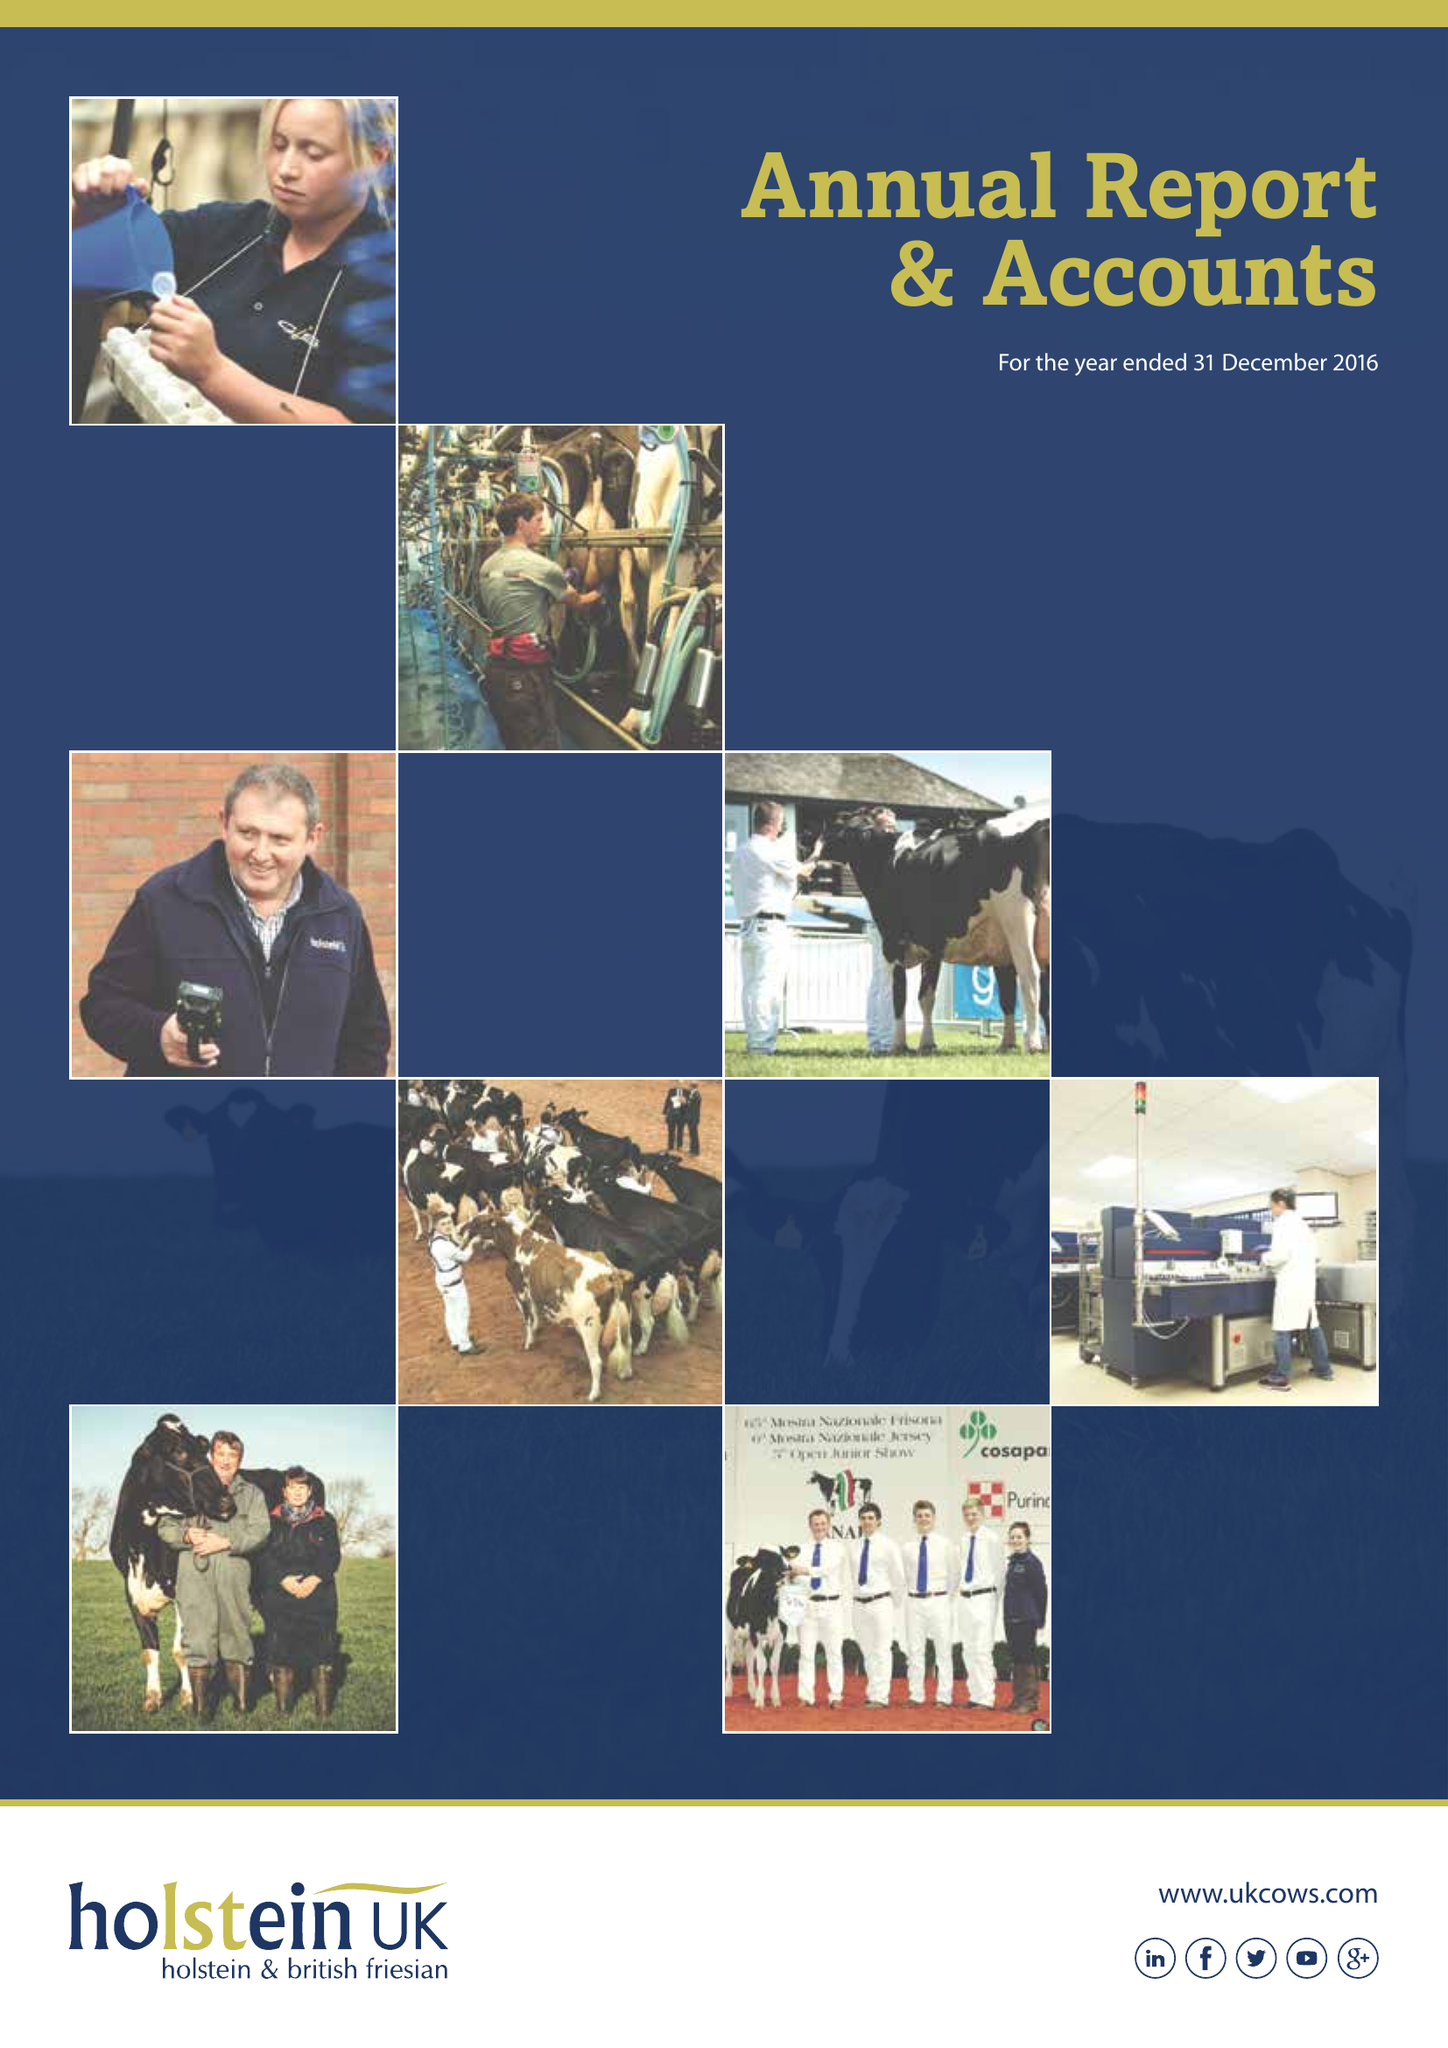What is the value for the report_date?
Answer the question using a single word or phrase. 2016-12-31 